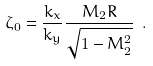<formula> <loc_0><loc_0><loc_500><loc_500>\zeta _ { 0 } = \frac { k _ { x } } { k _ { y } } \frac { M _ { 2 } R } { \sqrt { 1 - M _ { 2 } ^ { 2 } } } \ .</formula> 